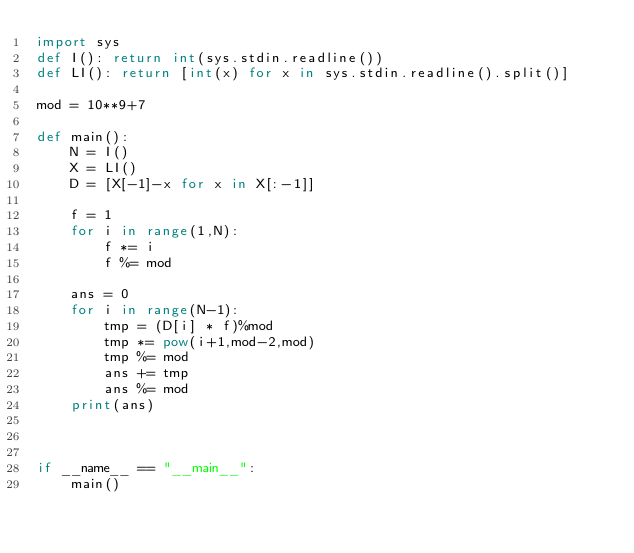<code> <loc_0><loc_0><loc_500><loc_500><_Python_>import sys
def I(): return int(sys.stdin.readline())
def LI(): return [int(x) for x in sys.stdin.readline().split()]

mod = 10**9+7

def main():
    N = I()
    X = LI()
    D = [X[-1]-x for x in X[:-1]]

    f = 1
    for i in range(1,N):
        f *= i
        f %= mod

    ans = 0
    for i in range(N-1):
        tmp = (D[i] * f)%mod
        tmp *= pow(i+1,mod-2,mod)
        tmp %= mod
        ans += tmp
        ans %= mod
    print(ans)



if __name__ == "__main__":
    main()
</code> 